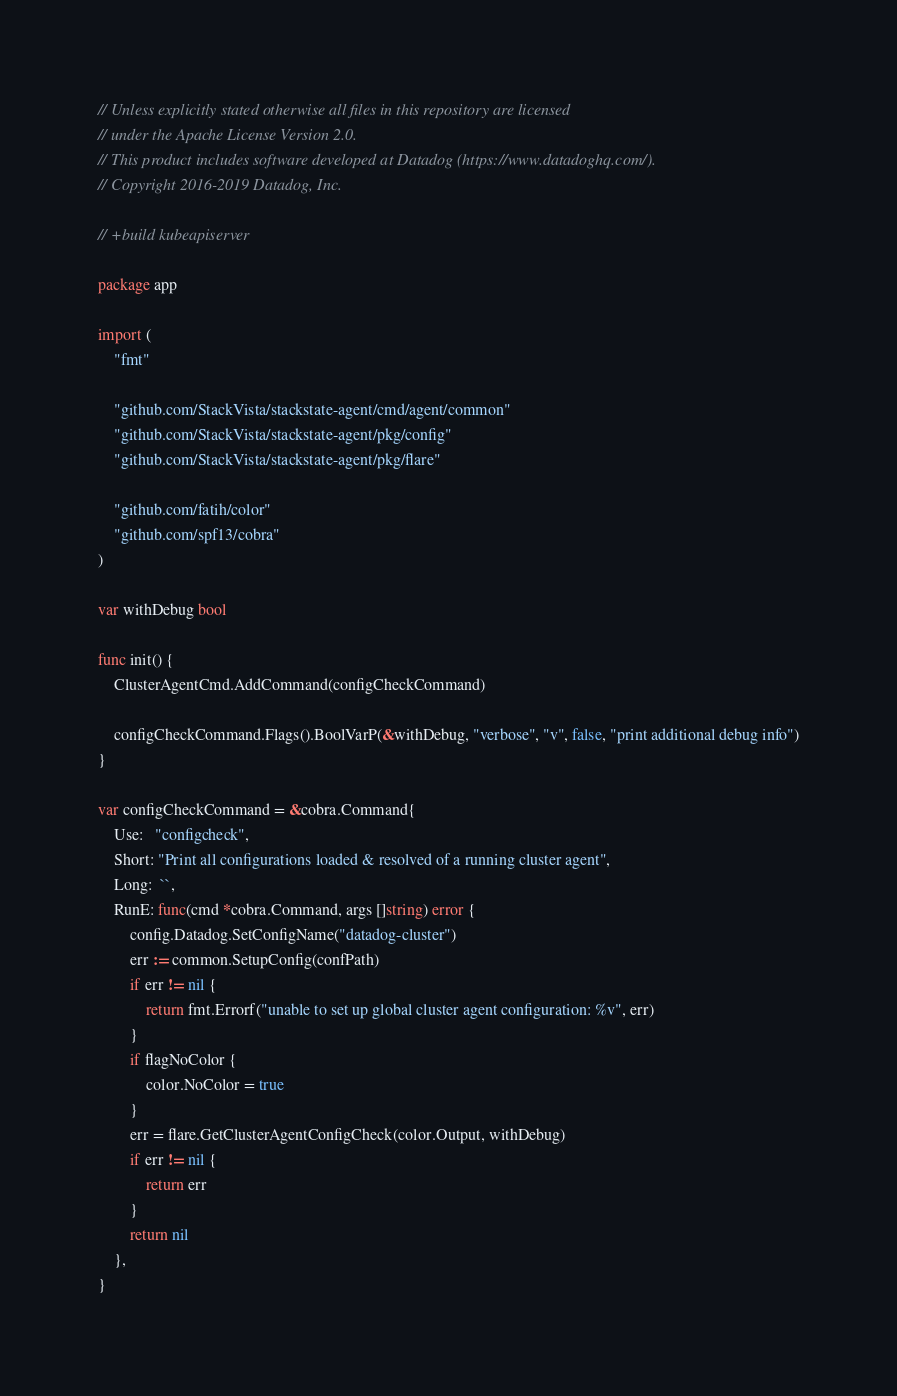Convert code to text. <code><loc_0><loc_0><loc_500><loc_500><_Go_>// Unless explicitly stated otherwise all files in this repository are licensed
// under the Apache License Version 2.0.
// This product includes software developed at Datadog (https://www.datadoghq.com/).
// Copyright 2016-2019 Datadog, Inc.

// +build kubeapiserver

package app

import (
	"fmt"

	"github.com/StackVista/stackstate-agent/cmd/agent/common"
	"github.com/StackVista/stackstate-agent/pkg/config"
	"github.com/StackVista/stackstate-agent/pkg/flare"

	"github.com/fatih/color"
	"github.com/spf13/cobra"
)

var withDebug bool

func init() {
	ClusterAgentCmd.AddCommand(configCheckCommand)

	configCheckCommand.Flags().BoolVarP(&withDebug, "verbose", "v", false, "print additional debug info")
}

var configCheckCommand = &cobra.Command{
	Use:   "configcheck",
	Short: "Print all configurations loaded & resolved of a running cluster agent",
	Long:  ``,
	RunE: func(cmd *cobra.Command, args []string) error {
		config.Datadog.SetConfigName("datadog-cluster")
		err := common.SetupConfig(confPath)
		if err != nil {
			return fmt.Errorf("unable to set up global cluster agent configuration: %v", err)
		}
		if flagNoColor {
			color.NoColor = true
		}
		err = flare.GetClusterAgentConfigCheck(color.Output, withDebug)
		if err != nil {
			return err
		}
		return nil
	},
}
</code> 